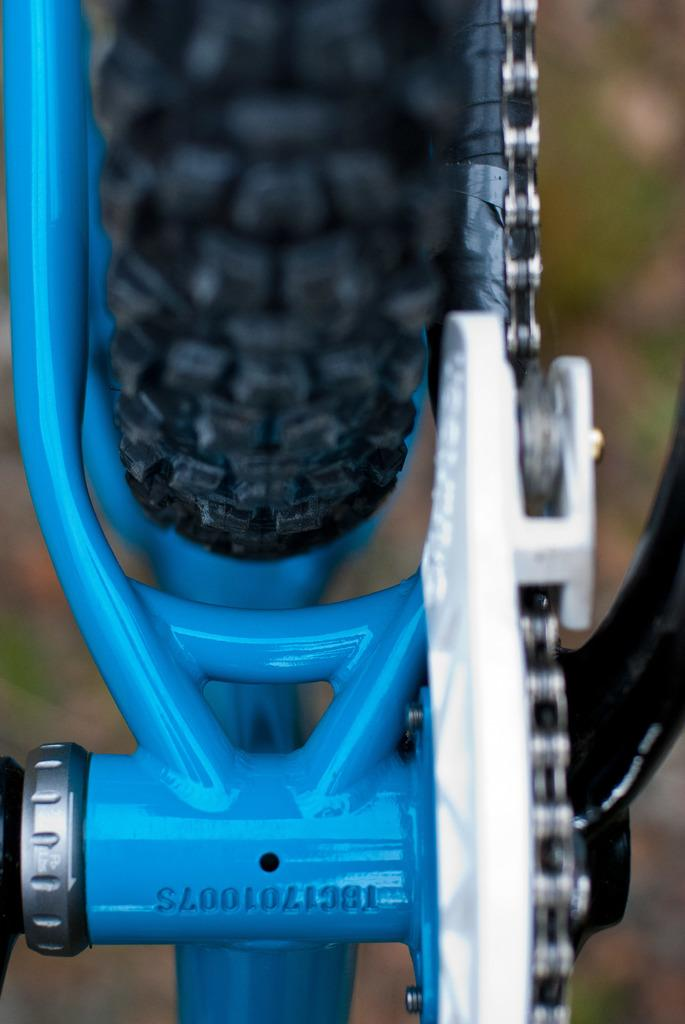What is the main subject of the image? There is an object in the image. Can you describe the colors of the object? The object has black, blue, and white colors. What does the object resemble? The object resembles a bicycle. How would you describe the background of the image? The background of the image is blurred. Can you see any pencils on the hill in the image? There is no hill or pencil present in the image. What type of chin is visible on the bicycle in the image? There is no chin visible in the image, as it features an object that resembles a bicycle, not an actual bicycle with a rider. 